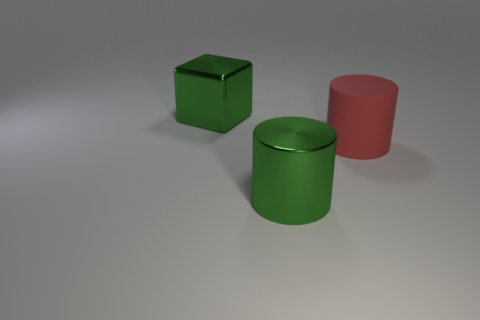Is there anything else of the same color as the shiny block?
Your answer should be very brief. Yes. There is a shiny thing that is the same color as the cube; what is its shape?
Make the answer very short. Cylinder. Do the large metallic object that is behind the red object and the metal cylinder have the same color?
Your response must be concise. Yes. What number of objects are small yellow metal things or large cubes?
Your answer should be very brief. 1. What number of other objects are the same material as the large cube?
Give a very brief answer. 1. Is there a thing behind the large green metallic thing in front of the large green shiny cube?
Give a very brief answer. Yes. What is the color of the other thing that is the same shape as the large matte object?
Ensure brevity in your answer.  Green. What is the size of the rubber object?
Your response must be concise. Large. Are there fewer big cylinders behind the large matte cylinder than cylinders?
Give a very brief answer. Yes. Is the material of the big block the same as the green object that is in front of the shiny block?
Provide a succinct answer. Yes. 